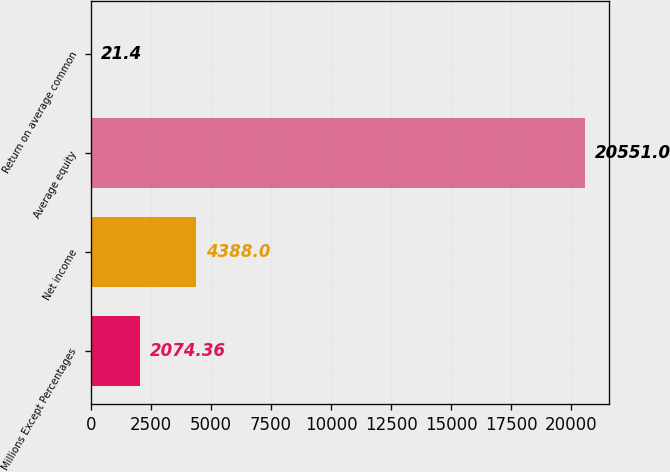Convert chart. <chart><loc_0><loc_0><loc_500><loc_500><bar_chart><fcel>Millions Except Percentages<fcel>Net income<fcel>Average equity<fcel>Return on average common<nl><fcel>2074.36<fcel>4388<fcel>20551<fcel>21.4<nl></chart> 